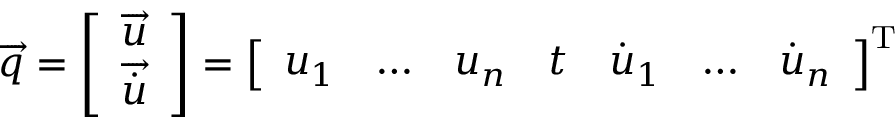<formula> <loc_0><loc_0><loc_500><loc_500>{ \overrightarrow { q } } = { \left [ \begin{array} { l } { { \overrightarrow { u } } } \\ { { \overrightarrow { \dot { u } } } } \end{array} \right ] } = { \left [ \begin{array} { l l l l l l l } { u _ { 1 } } & { \dots } & { u _ { n } } & { t } & { { \dot { u } } _ { 1 } } & { \dots } & { { \dot { u } } _ { n } } \end{array} \right ] } ^ { T }</formula> 